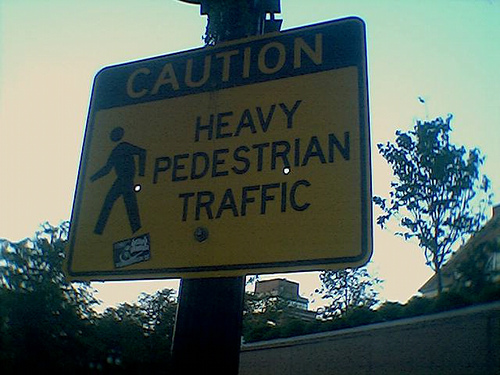How many people are visible? No people are visible in the image. The picture shows a caution sign for heavy pedestrian traffic, but there are no actual pedestrians captured in the shot. 